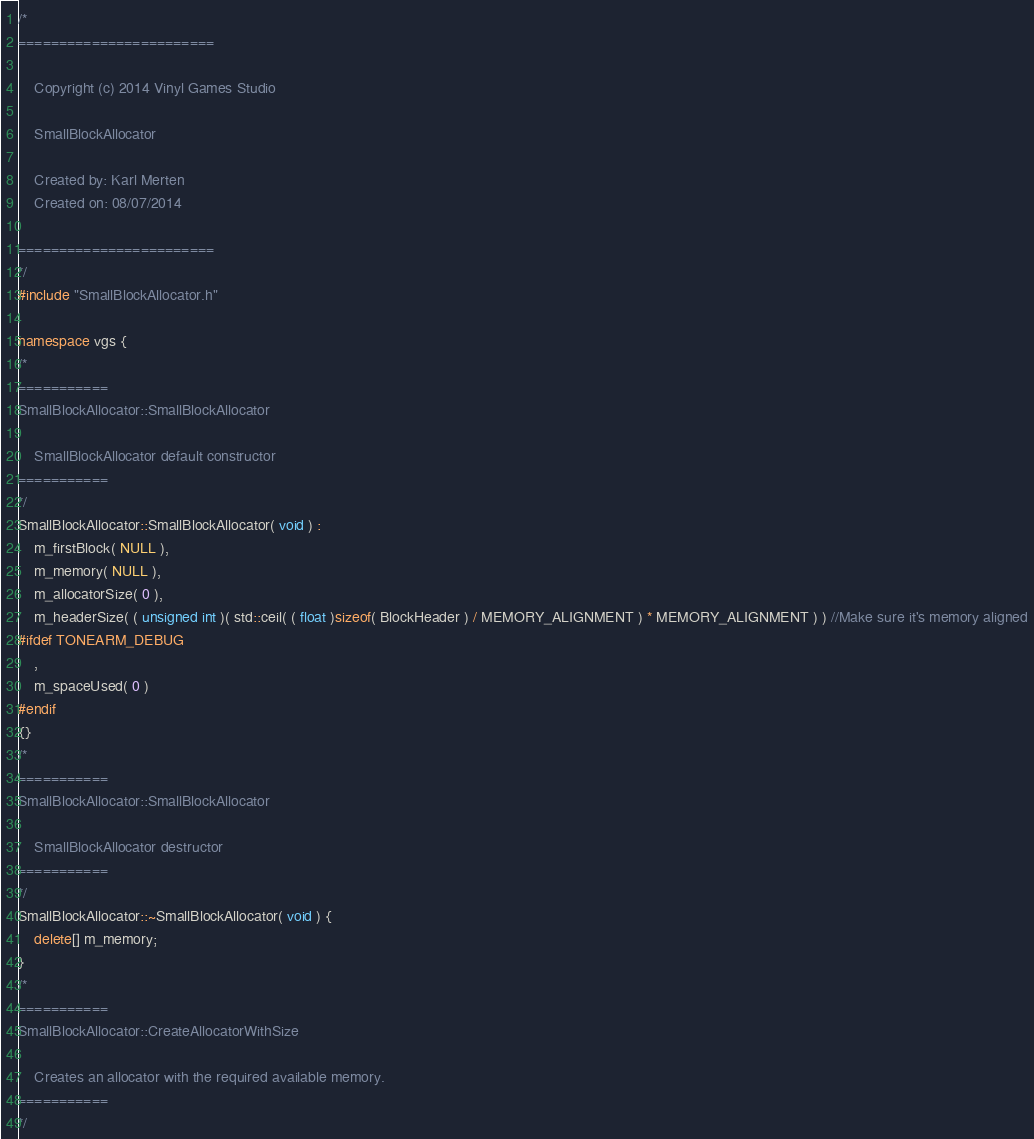Convert code to text. <code><loc_0><loc_0><loc_500><loc_500><_C++_>/*
========================

	Copyright (c) 2014 Vinyl Games Studio

	SmallBlockAllocator

	Created by: Karl Merten
	Created on: 08/07/2014

========================
*/
#include "SmallBlockAllocator.h"

namespace vgs {
/*
===========
SmallBlockAllocator::SmallBlockAllocator

	SmallBlockAllocator default constructor
===========
*/
SmallBlockAllocator::SmallBlockAllocator( void ) :
	m_firstBlock( NULL ),
	m_memory( NULL ),
	m_allocatorSize( 0 ),
	m_headerSize( ( unsigned int )( std::ceil( ( float )sizeof( BlockHeader ) / MEMORY_ALIGNMENT ) * MEMORY_ALIGNMENT ) ) //Make sure it's memory aligned
#ifdef TONEARM_DEBUG
	,
	m_spaceUsed( 0 )
#endif
{}
/*
===========
SmallBlockAllocator::SmallBlockAllocator

	SmallBlockAllocator destructor
===========
*/
SmallBlockAllocator::~SmallBlockAllocator( void ) {
	delete[] m_memory;
}
/*
===========
SmallBlockAllocator::CreateAllocatorWithSize

	Creates an allocator with the required available memory.
===========
*/</code> 